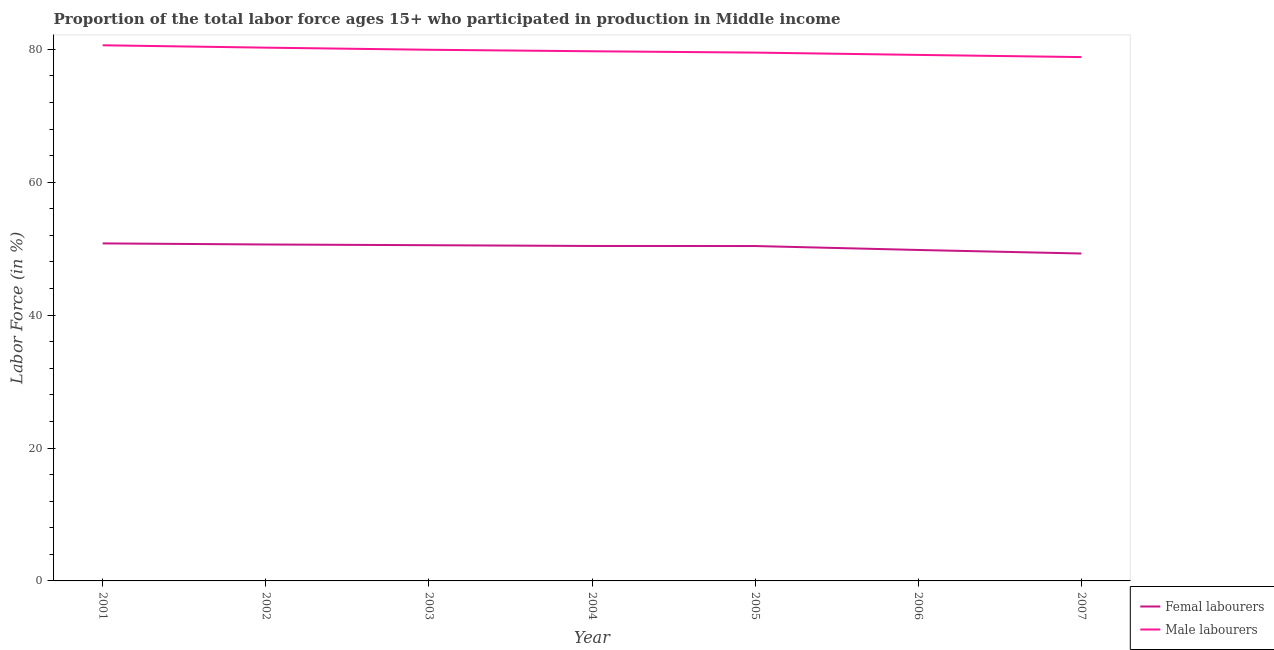How many different coloured lines are there?
Your answer should be very brief. 2. Does the line corresponding to percentage of female labor force intersect with the line corresponding to percentage of male labour force?
Offer a terse response. No. What is the percentage of female labor force in 2006?
Ensure brevity in your answer.  49.81. Across all years, what is the maximum percentage of male labour force?
Your answer should be very brief. 80.62. Across all years, what is the minimum percentage of female labor force?
Your response must be concise. 49.28. In which year was the percentage of female labor force minimum?
Give a very brief answer. 2007. What is the total percentage of male labour force in the graph?
Your answer should be compact. 558.06. What is the difference between the percentage of male labour force in 2004 and that in 2005?
Provide a short and direct response. 0.2. What is the difference between the percentage of female labor force in 2007 and the percentage of male labour force in 2001?
Your answer should be compact. -31.34. What is the average percentage of male labour force per year?
Provide a succinct answer. 79.72. In the year 2003, what is the difference between the percentage of male labour force and percentage of female labor force?
Your response must be concise. 29.41. What is the ratio of the percentage of male labour force in 2002 to that in 2005?
Keep it short and to the point. 1.01. Is the difference between the percentage of male labour force in 2005 and 2007 greater than the difference between the percentage of female labor force in 2005 and 2007?
Make the answer very short. No. What is the difference between the highest and the second highest percentage of male labour force?
Make the answer very short. 0.36. What is the difference between the highest and the lowest percentage of male labour force?
Your answer should be compact. 1.78. Is the percentage of male labour force strictly less than the percentage of female labor force over the years?
Make the answer very short. No. How many years are there in the graph?
Your response must be concise. 7. Are the values on the major ticks of Y-axis written in scientific E-notation?
Your answer should be very brief. No. Does the graph contain grids?
Provide a short and direct response. No. Where does the legend appear in the graph?
Keep it short and to the point. Bottom right. What is the title of the graph?
Ensure brevity in your answer.  Proportion of the total labor force ages 15+ who participated in production in Middle income. What is the label or title of the X-axis?
Ensure brevity in your answer.  Year. What is the label or title of the Y-axis?
Provide a short and direct response. Labor Force (in %). What is the Labor Force (in %) in Femal labourers in 2001?
Your answer should be very brief. 50.8. What is the Labor Force (in %) in Male labourers in 2001?
Ensure brevity in your answer.  80.62. What is the Labor Force (in %) in Femal labourers in 2002?
Keep it short and to the point. 50.64. What is the Labor Force (in %) in Male labourers in 2002?
Provide a short and direct response. 80.26. What is the Labor Force (in %) of Femal labourers in 2003?
Offer a very short reply. 50.53. What is the Labor Force (in %) of Male labourers in 2003?
Make the answer very short. 79.94. What is the Labor Force (in %) of Femal labourers in 2004?
Give a very brief answer. 50.41. What is the Labor Force (in %) of Male labourers in 2004?
Make the answer very short. 79.72. What is the Labor Force (in %) in Femal labourers in 2005?
Provide a short and direct response. 50.4. What is the Labor Force (in %) in Male labourers in 2005?
Keep it short and to the point. 79.52. What is the Labor Force (in %) in Femal labourers in 2006?
Your answer should be very brief. 49.81. What is the Labor Force (in %) in Male labourers in 2006?
Provide a short and direct response. 79.17. What is the Labor Force (in %) of Femal labourers in 2007?
Offer a very short reply. 49.28. What is the Labor Force (in %) in Male labourers in 2007?
Provide a short and direct response. 78.84. Across all years, what is the maximum Labor Force (in %) in Femal labourers?
Your answer should be compact. 50.8. Across all years, what is the maximum Labor Force (in %) of Male labourers?
Give a very brief answer. 80.62. Across all years, what is the minimum Labor Force (in %) in Femal labourers?
Offer a terse response. 49.28. Across all years, what is the minimum Labor Force (in %) of Male labourers?
Provide a short and direct response. 78.84. What is the total Labor Force (in %) in Femal labourers in the graph?
Offer a terse response. 351.86. What is the total Labor Force (in %) of Male labourers in the graph?
Provide a short and direct response. 558.06. What is the difference between the Labor Force (in %) of Femal labourers in 2001 and that in 2002?
Offer a terse response. 0.16. What is the difference between the Labor Force (in %) in Male labourers in 2001 and that in 2002?
Provide a succinct answer. 0.36. What is the difference between the Labor Force (in %) of Femal labourers in 2001 and that in 2003?
Keep it short and to the point. 0.27. What is the difference between the Labor Force (in %) in Male labourers in 2001 and that in 2003?
Give a very brief answer. 0.67. What is the difference between the Labor Force (in %) in Femal labourers in 2001 and that in 2004?
Ensure brevity in your answer.  0.39. What is the difference between the Labor Force (in %) in Male labourers in 2001 and that in 2004?
Ensure brevity in your answer.  0.9. What is the difference between the Labor Force (in %) in Femal labourers in 2001 and that in 2005?
Your answer should be compact. 0.39. What is the difference between the Labor Force (in %) of Male labourers in 2001 and that in 2005?
Offer a terse response. 1.1. What is the difference between the Labor Force (in %) of Femal labourers in 2001 and that in 2006?
Make the answer very short. 0.99. What is the difference between the Labor Force (in %) of Male labourers in 2001 and that in 2006?
Your answer should be compact. 1.45. What is the difference between the Labor Force (in %) of Femal labourers in 2001 and that in 2007?
Offer a very short reply. 1.52. What is the difference between the Labor Force (in %) of Male labourers in 2001 and that in 2007?
Provide a succinct answer. 1.78. What is the difference between the Labor Force (in %) in Femal labourers in 2002 and that in 2003?
Provide a short and direct response. 0.11. What is the difference between the Labor Force (in %) in Male labourers in 2002 and that in 2003?
Your answer should be compact. 0.32. What is the difference between the Labor Force (in %) in Femal labourers in 2002 and that in 2004?
Provide a short and direct response. 0.23. What is the difference between the Labor Force (in %) in Male labourers in 2002 and that in 2004?
Your answer should be compact. 0.54. What is the difference between the Labor Force (in %) of Femal labourers in 2002 and that in 2005?
Your answer should be very brief. 0.23. What is the difference between the Labor Force (in %) of Male labourers in 2002 and that in 2005?
Make the answer very short. 0.74. What is the difference between the Labor Force (in %) of Femal labourers in 2002 and that in 2006?
Offer a terse response. 0.83. What is the difference between the Labor Force (in %) of Male labourers in 2002 and that in 2006?
Offer a terse response. 1.09. What is the difference between the Labor Force (in %) in Femal labourers in 2002 and that in 2007?
Offer a terse response. 1.36. What is the difference between the Labor Force (in %) of Male labourers in 2002 and that in 2007?
Your answer should be very brief. 1.42. What is the difference between the Labor Force (in %) in Femal labourers in 2003 and that in 2004?
Offer a very short reply. 0.12. What is the difference between the Labor Force (in %) in Male labourers in 2003 and that in 2004?
Make the answer very short. 0.23. What is the difference between the Labor Force (in %) of Femal labourers in 2003 and that in 2005?
Provide a succinct answer. 0.12. What is the difference between the Labor Force (in %) in Male labourers in 2003 and that in 2005?
Keep it short and to the point. 0.43. What is the difference between the Labor Force (in %) in Femal labourers in 2003 and that in 2006?
Provide a succinct answer. 0.72. What is the difference between the Labor Force (in %) of Male labourers in 2003 and that in 2006?
Give a very brief answer. 0.77. What is the difference between the Labor Force (in %) of Femal labourers in 2003 and that in 2007?
Keep it short and to the point. 1.25. What is the difference between the Labor Force (in %) in Male labourers in 2003 and that in 2007?
Give a very brief answer. 1.1. What is the difference between the Labor Force (in %) in Femal labourers in 2004 and that in 2005?
Offer a very short reply. 0.01. What is the difference between the Labor Force (in %) of Femal labourers in 2004 and that in 2006?
Keep it short and to the point. 0.6. What is the difference between the Labor Force (in %) of Male labourers in 2004 and that in 2006?
Your answer should be very brief. 0.55. What is the difference between the Labor Force (in %) of Femal labourers in 2004 and that in 2007?
Provide a short and direct response. 1.14. What is the difference between the Labor Force (in %) in Male labourers in 2004 and that in 2007?
Your response must be concise. 0.88. What is the difference between the Labor Force (in %) in Femal labourers in 2005 and that in 2006?
Make the answer very short. 0.59. What is the difference between the Labor Force (in %) of Male labourers in 2005 and that in 2006?
Your response must be concise. 0.35. What is the difference between the Labor Force (in %) in Femal labourers in 2005 and that in 2007?
Your response must be concise. 1.13. What is the difference between the Labor Force (in %) of Male labourers in 2005 and that in 2007?
Offer a terse response. 0.68. What is the difference between the Labor Force (in %) of Femal labourers in 2006 and that in 2007?
Offer a terse response. 0.53. What is the difference between the Labor Force (in %) in Male labourers in 2006 and that in 2007?
Offer a terse response. 0.33. What is the difference between the Labor Force (in %) of Femal labourers in 2001 and the Labor Force (in %) of Male labourers in 2002?
Make the answer very short. -29.46. What is the difference between the Labor Force (in %) of Femal labourers in 2001 and the Labor Force (in %) of Male labourers in 2003?
Your response must be concise. -29.14. What is the difference between the Labor Force (in %) in Femal labourers in 2001 and the Labor Force (in %) in Male labourers in 2004?
Keep it short and to the point. -28.92. What is the difference between the Labor Force (in %) in Femal labourers in 2001 and the Labor Force (in %) in Male labourers in 2005?
Ensure brevity in your answer.  -28.72. What is the difference between the Labor Force (in %) of Femal labourers in 2001 and the Labor Force (in %) of Male labourers in 2006?
Ensure brevity in your answer.  -28.37. What is the difference between the Labor Force (in %) of Femal labourers in 2001 and the Labor Force (in %) of Male labourers in 2007?
Offer a very short reply. -28.04. What is the difference between the Labor Force (in %) in Femal labourers in 2002 and the Labor Force (in %) in Male labourers in 2003?
Make the answer very short. -29.31. What is the difference between the Labor Force (in %) of Femal labourers in 2002 and the Labor Force (in %) of Male labourers in 2004?
Give a very brief answer. -29.08. What is the difference between the Labor Force (in %) of Femal labourers in 2002 and the Labor Force (in %) of Male labourers in 2005?
Your answer should be compact. -28.88. What is the difference between the Labor Force (in %) of Femal labourers in 2002 and the Labor Force (in %) of Male labourers in 2006?
Provide a succinct answer. -28.53. What is the difference between the Labor Force (in %) of Femal labourers in 2002 and the Labor Force (in %) of Male labourers in 2007?
Ensure brevity in your answer.  -28.2. What is the difference between the Labor Force (in %) of Femal labourers in 2003 and the Labor Force (in %) of Male labourers in 2004?
Give a very brief answer. -29.19. What is the difference between the Labor Force (in %) in Femal labourers in 2003 and the Labor Force (in %) in Male labourers in 2005?
Offer a very short reply. -28.99. What is the difference between the Labor Force (in %) of Femal labourers in 2003 and the Labor Force (in %) of Male labourers in 2006?
Provide a short and direct response. -28.64. What is the difference between the Labor Force (in %) in Femal labourers in 2003 and the Labor Force (in %) in Male labourers in 2007?
Your answer should be very brief. -28.31. What is the difference between the Labor Force (in %) in Femal labourers in 2004 and the Labor Force (in %) in Male labourers in 2005?
Ensure brevity in your answer.  -29.11. What is the difference between the Labor Force (in %) of Femal labourers in 2004 and the Labor Force (in %) of Male labourers in 2006?
Your answer should be very brief. -28.76. What is the difference between the Labor Force (in %) of Femal labourers in 2004 and the Labor Force (in %) of Male labourers in 2007?
Offer a very short reply. -28.43. What is the difference between the Labor Force (in %) in Femal labourers in 2005 and the Labor Force (in %) in Male labourers in 2006?
Offer a very short reply. -28.76. What is the difference between the Labor Force (in %) in Femal labourers in 2005 and the Labor Force (in %) in Male labourers in 2007?
Provide a short and direct response. -28.44. What is the difference between the Labor Force (in %) of Femal labourers in 2006 and the Labor Force (in %) of Male labourers in 2007?
Give a very brief answer. -29.03. What is the average Labor Force (in %) in Femal labourers per year?
Keep it short and to the point. 50.27. What is the average Labor Force (in %) in Male labourers per year?
Your answer should be compact. 79.72. In the year 2001, what is the difference between the Labor Force (in %) in Femal labourers and Labor Force (in %) in Male labourers?
Your answer should be very brief. -29.82. In the year 2002, what is the difference between the Labor Force (in %) in Femal labourers and Labor Force (in %) in Male labourers?
Offer a terse response. -29.62. In the year 2003, what is the difference between the Labor Force (in %) of Femal labourers and Labor Force (in %) of Male labourers?
Keep it short and to the point. -29.41. In the year 2004, what is the difference between the Labor Force (in %) in Femal labourers and Labor Force (in %) in Male labourers?
Give a very brief answer. -29.31. In the year 2005, what is the difference between the Labor Force (in %) of Femal labourers and Labor Force (in %) of Male labourers?
Offer a terse response. -29.11. In the year 2006, what is the difference between the Labor Force (in %) in Femal labourers and Labor Force (in %) in Male labourers?
Make the answer very short. -29.36. In the year 2007, what is the difference between the Labor Force (in %) of Femal labourers and Labor Force (in %) of Male labourers?
Ensure brevity in your answer.  -29.56. What is the ratio of the Labor Force (in %) of Male labourers in 2001 to that in 2002?
Your response must be concise. 1. What is the ratio of the Labor Force (in %) of Male labourers in 2001 to that in 2003?
Provide a succinct answer. 1.01. What is the ratio of the Labor Force (in %) in Femal labourers in 2001 to that in 2004?
Keep it short and to the point. 1.01. What is the ratio of the Labor Force (in %) of Male labourers in 2001 to that in 2004?
Provide a succinct answer. 1.01. What is the ratio of the Labor Force (in %) in Femal labourers in 2001 to that in 2005?
Provide a succinct answer. 1.01. What is the ratio of the Labor Force (in %) in Male labourers in 2001 to that in 2005?
Keep it short and to the point. 1.01. What is the ratio of the Labor Force (in %) of Femal labourers in 2001 to that in 2006?
Your response must be concise. 1.02. What is the ratio of the Labor Force (in %) in Male labourers in 2001 to that in 2006?
Provide a succinct answer. 1.02. What is the ratio of the Labor Force (in %) in Femal labourers in 2001 to that in 2007?
Keep it short and to the point. 1.03. What is the ratio of the Labor Force (in %) in Male labourers in 2001 to that in 2007?
Keep it short and to the point. 1.02. What is the ratio of the Labor Force (in %) in Femal labourers in 2002 to that in 2003?
Make the answer very short. 1. What is the ratio of the Labor Force (in %) of Male labourers in 2002 to that in 2003?
Keep it short and to the point. 1. What is the ratio of the Labor Force (in %) of Femal labourers in 2002 to that in 2004?
Provide a short and direct response. 1. What is the ratio of the Labor Force (in %) in Male labourers in 2002 to that in 2004?
Offer a very short reply. 1.01. What is the ratio of the Labor Force (in %) in Femal labourers in 2002 to that in 2005?
Your response must be concise. 1. What is the ratio of the Labor Force (in %) in Male labourers in 2002 to that in 2005?
Provide a short and direct response. 1.01. What is the ratio of the Labor Force (in %) in Femal labourers in 2002 to that in 2006?
Offer a terse response. 1.02. What is the ratio of the Labor Force (in %) in Male labourers in 2002 to that in 2006?
Make the answer very short. 1.01. What is the ratio of the Labor Force (in %) of Femal labourers in 2002 to that in 2007?
Ensure brevity in your answer.  1.03. What is the ratio of the Labor Force (in %) in Femal labourers in 2003 to that in 2004?
Offer a very short reply. 1. What is the ratio of the Labor Force (in %) in Male labourers in 2003 to that in 2004?
Your answer should be very brief. 1. What is the ratio of the Labor Force (in %) of Male labourers in 2003 to that in 2005?
Provide a succinct answer. 1.01. What is the ratio of the Labor Force (in %) of Femal labourers in 2003 to that in 2006?
Keep it short and to the point. 1.01. What is the ratio of the Labor Force (in %) in Male labourers in 2003 to that in 2006?
Give a very brief answer. 1.01. What is the ratio of the Labor Force (in %) of Femal labourers in 2003 to that in 2007?
Provide a short and direct response. 1.03. What is the ratio of the Labor Force (in %) of Femal labourers in 2004 to that in 2006?
Provide a succinct answer. 1.01. What is the ratio of the Labor Force (in %) in Femal labourers in 2004 to that in 2007?
Ensure brevity in your answer.  1.02. What is the ratio of the Labor Force (in %) of Male labourers in 2004 to that in 2007?
Provide a short and direct response. 1.01. What is the ratio of the Labor Force (in %) in Femal labourers in 2005 to that in 2006?
Make the answer very short. 1.01. What is the ratio of the Labor Force (in %) in Femal labourers in 2005 to that in 2007?
Offer a terse response. 1.02. What is the ratio of the Labor Force (in %) in Male labourers in 2005 to that in 2007?
Your answer should be very brief. 1.01. What is the ratio of the Labor Force (in %) of Femal labourers in 2006 to that in 2007?
Provide a succinct answer. 1.01. What is the ratio of the Labor Force (in %) in Male labourers in 2006 to that in 2007?
Ensure brevity in your answer.  1. What is the difference between the highest and the second highest Labor Force (in %) in Femal labourers?
Ensure brevity in your answer.  0.16. What is the difference between the highest and the second highest Labor Force (in %) of Male labourers?
Make the answer very short. 0.36. What is the difference between the highest and the lowest Labor Force (in %) of Femal labourers?
Your response must be concise. 1.52. What is the difference between the highest and the lowest Labor Force (in %) in Male labourers?
Keep it short and to the point. 1.78. 